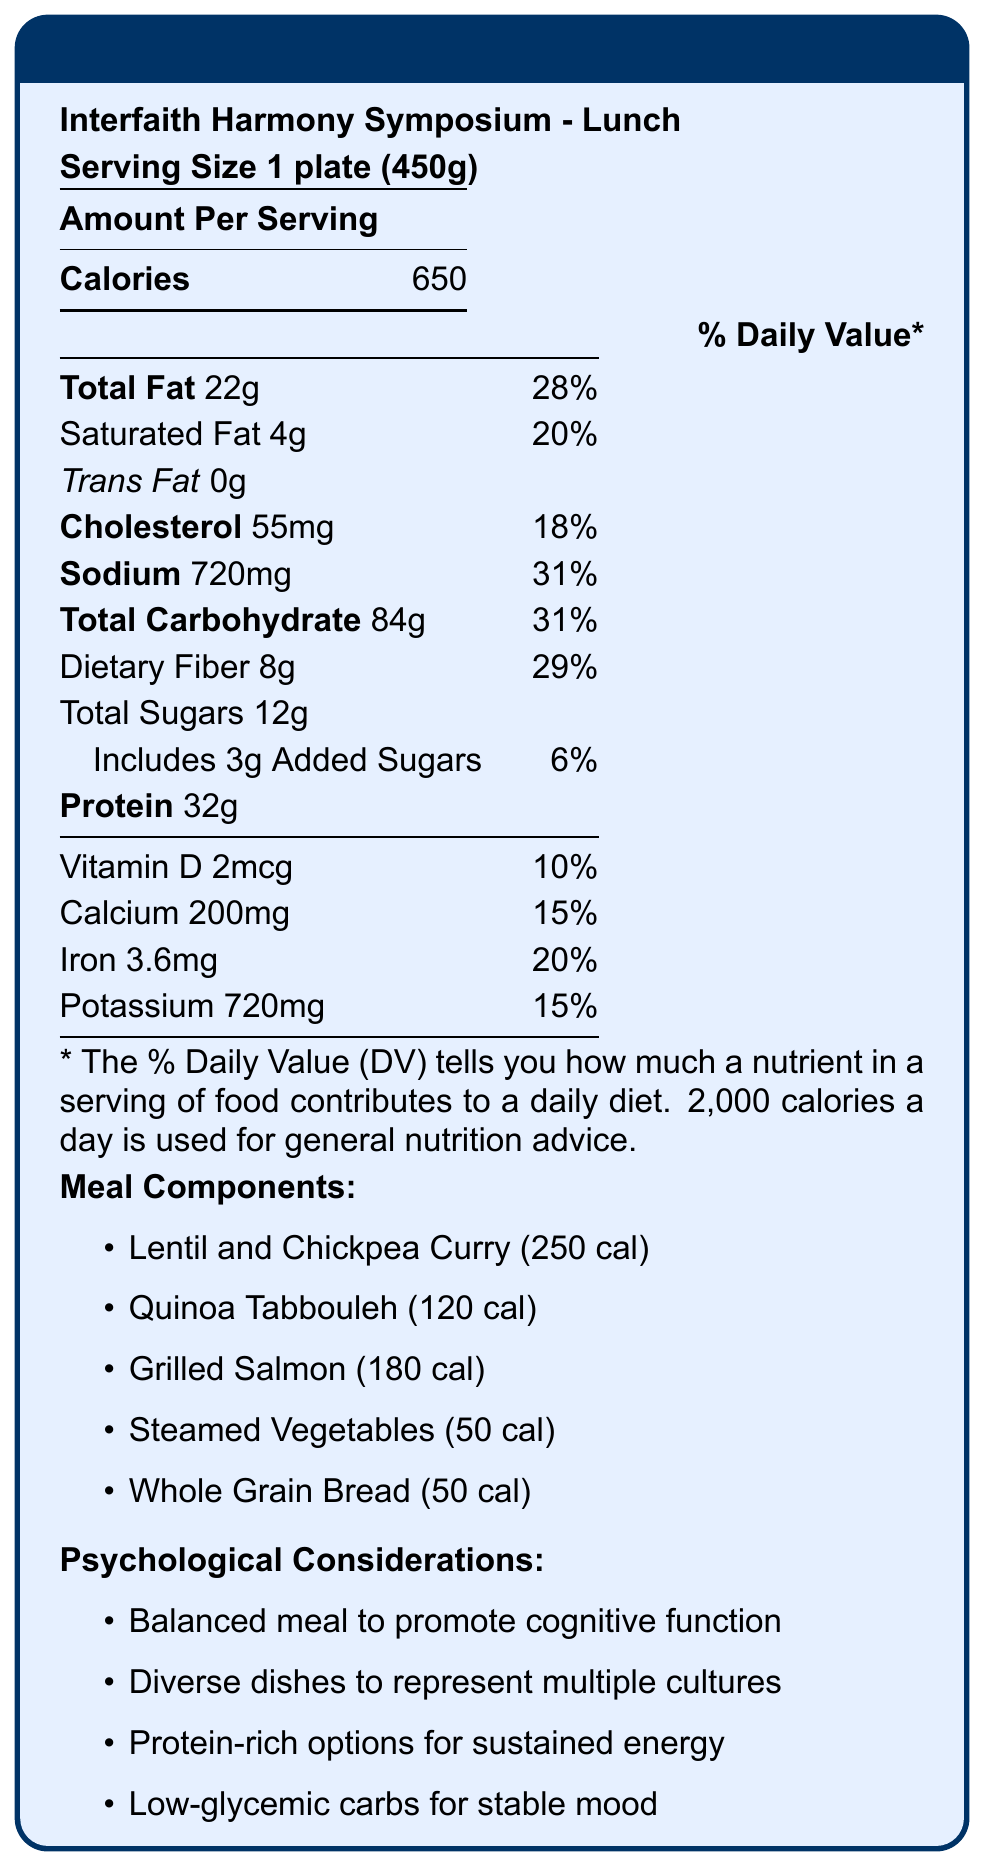what is the total calorie count for the meal? The document clearly states that the total calorie count per serving size of 1 plate (450g) is 650 calories.
Answer: 650 calories How much saturated fat is in the meal? The document lists the saturated fat content in the meal as 4 grams.
Answer: 4g What percentage of the daily value of sodium does the meal contain? The document indicates that the sodium content is 720mg, which is 31% of the daily value.
Answer: 31% How many grams of total sugars are in the meal? The document details that the total sugars amount to 12 grams.
Answer: 12g Name one psychological consideration mentioned for the meal. One psychological consideration listed in the document is that the meal is balanced to promote cognitive function during discussions.
Answer: Balanced meal to promote cognitive function during discussions What is the primary source of protein in the meal? A. Lentil and Chickpea Curry B. Quinoa Tabbouleh C. Grilled Salmon Grilled Salmon has the highest protein content out of the options listed, and protein content is specifically a psychological consideration.
Answer: C. Grilled Salmon Which component of the meal has the highest calorie content? A. Lentil and Chickpea Curry B. Quinoa Tabbouleh C. Whole Grain Bread The Lentil and Chickpea Curry has 250 calories, which is the highest among the listed meal components.
Answer: A. Lentil and Chickpea Curry How much dietary fiber does the meal contain? A. 5g B. 8g C. 10g The document lists the dietary fiber content as 8 grams, matching option B.
Answer: B. 8g Does the meal include Halal and Kosher certified ingredients? The document lists that Halal and Kosher certified ingredients are used in the meal.
Answer: Yes Summarize the main points in the document. The document provides detailed nutritional information for lunch served at the Interfaith Harmony Symposium, including caloric content, macronutrients, and vitamins/minerals. It also highlights psychological considerations, religious accommodations, sustainability efforts, and nutritional goals to support the symposium's objectives.
Answer: A balanced meal for the Interfaith Harmony Symposium lunch promotes cognitive function with a total of 650 calories per serving. The meal includes a variety of components representing different cultures, features multiple health benefits, and adheres to religious dietary requirements while also focusing on sustainability efforts. What are the total serving sizes for each meal component? The document provides calorie information per component but does not specify the serving sizes for each individual component.
Answer: Not enough information 